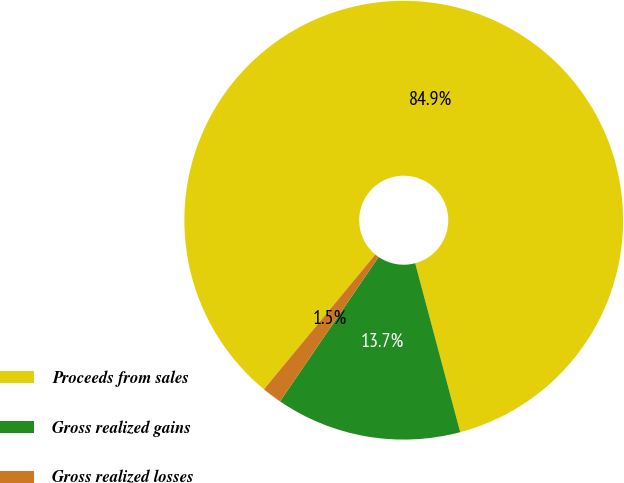Convert chart. <chart><loc_0><loc_0><loc_500><loc_500><pie_chart><fcel>Proceeds from sales<fcel>Gross realized gains<fcel>Gross realized losses<nl><fcel>84.85%<fcel>13.68%<fcel>1.46%<nl></chart> 